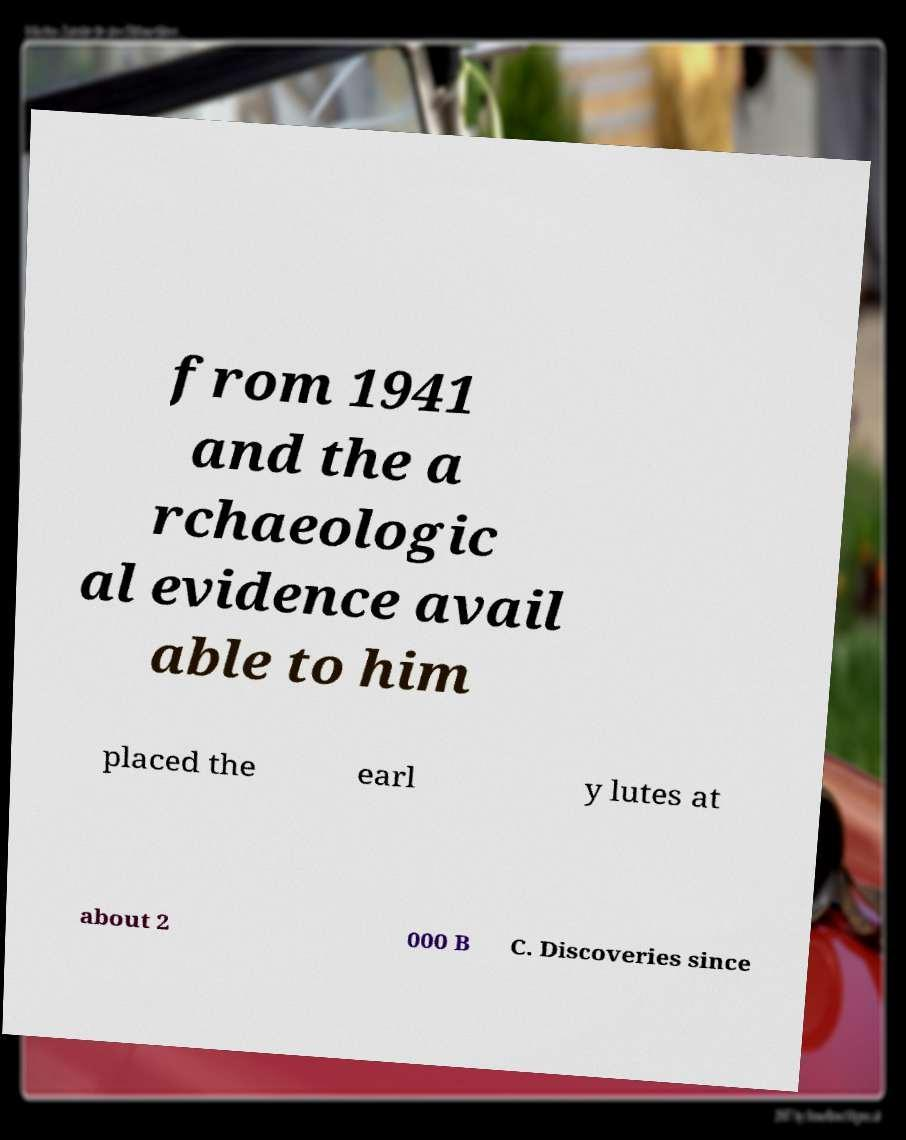There's text embedded in this image that I need extracted. Can you transcribe it verbatim? from 1941 and the a rchaeologic al evidence avail able to him placed the earl y lutes at about 2 000 B C. Discoveries since 